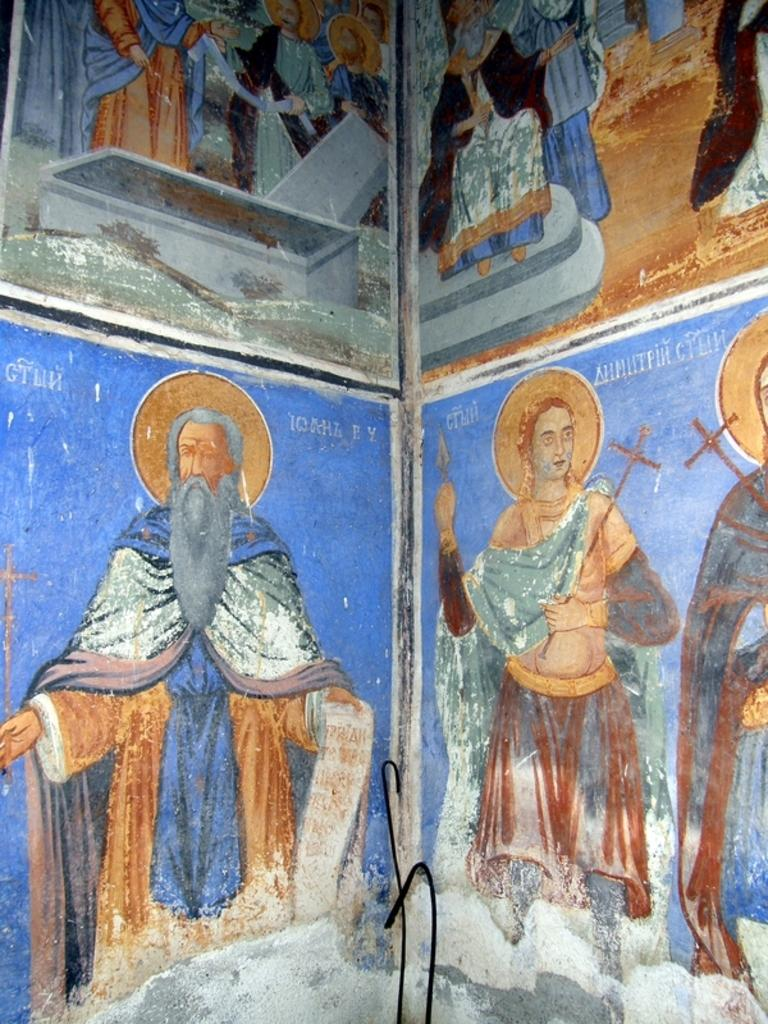What is on the wall in the image? There are paintings on the wall in the image. Can you describe the paintings in any way? Unfortunately, the provided facts do not give any information about the appearance or content of the paintings. Are there any other objects or features on the wall besides the paintings? The provided facts do not mention any other objects or features on the wall. What type of tail can be seen on the painting of the animal in the image? There is no painting of an animal with a tail present in the image. 